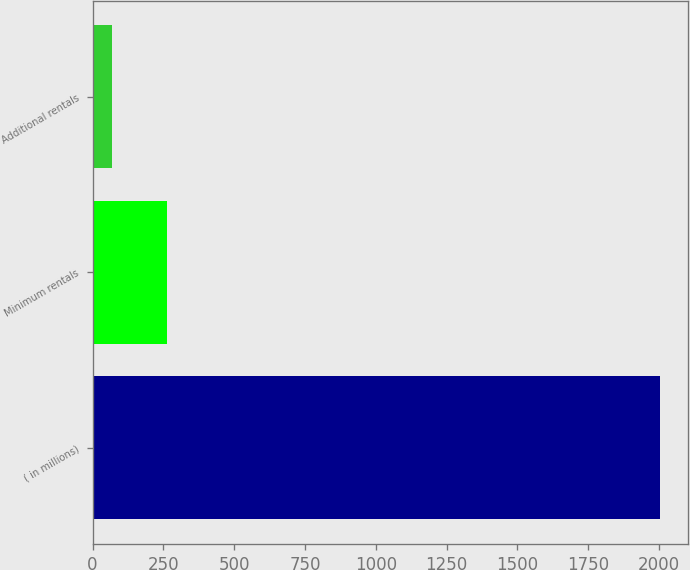Convert chart to OTSL. <chart><loc_0><loc_0><loc_500><loc_500><bar_chart><fcel>( in millions)<fcel>Minimum rentals<fcel>Additional rentals<nl><fcel>2003<fcel>261.5<fcel>68<nl></chart> 